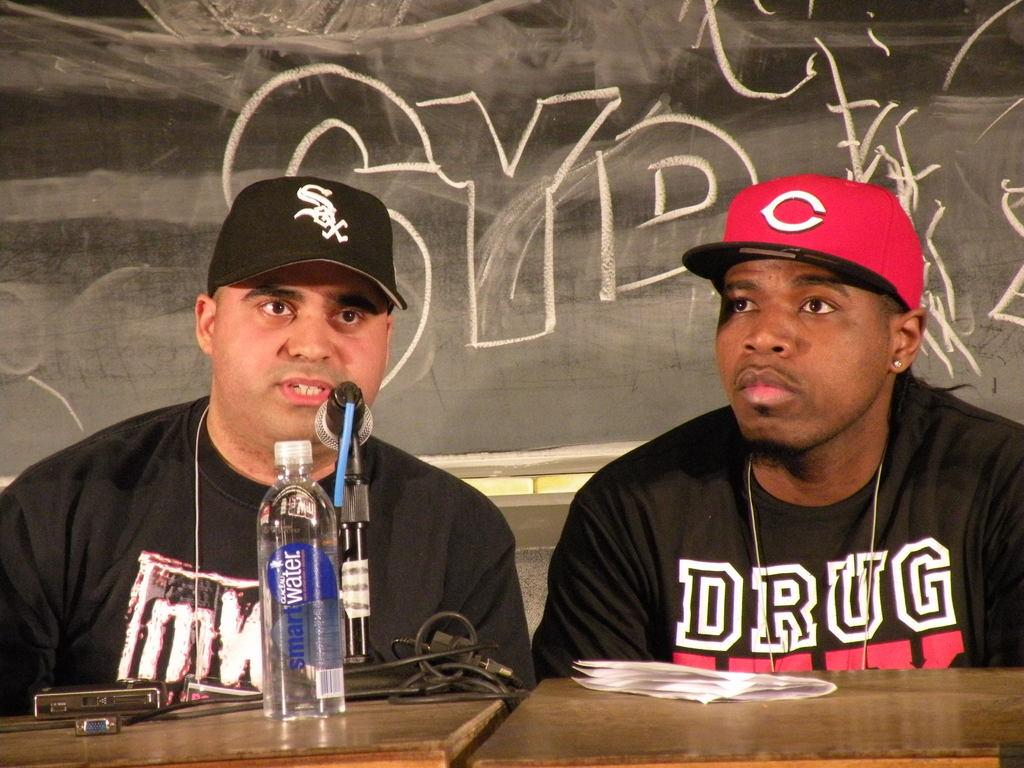<image>
Describe the image concisely. Two baseball players are conducting an interview while the player from the White Sox has a bottle of Smart Water in front of him. 